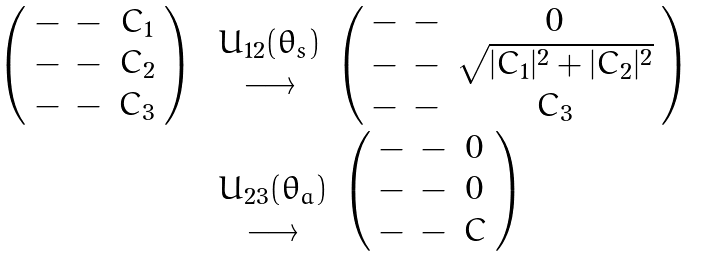Convert formula to latex. <formula><loc_0><loc_0><loc_500><loc_500>\begin{array} { l l } \left ( \begin{array} { c c c } - & - & C _ { 1 } \\ - & - & C _ { 2 } \\ - & - & C _ { 3 } \end{array} \right ) & \begin{array} { c } U _ { 1 2 } ( \theta _ { s } ) \\ \longrightarrow \\ \end{array} \left ( \begin{array} { c c c } - & - & 0 \\ - & - & \sqrt { | C _ { 1 } | ^ { 2 } + | C _ { 2 } | ^ { 2 } } \\ - & - & C _ { 3 } \end{array} \right ) \\ & \begin{array} { c } \\ U _ { 2 3 } ( \theta _ { a } ) \\ \longrightarrow \\ \end{array} \left ( \begin{array} { c c c } - & - & 0 \\ - & - & 0 \\ - & - & C \end{array} \right ) \end{array}</formula> 